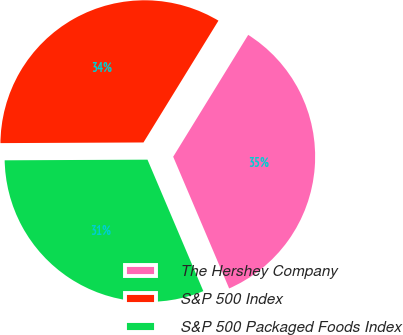Convert chart. <chart><loc_0><loc_0><loc_500><loc_500><pie_chart><fcel>The Hershey Company<fcel>S&P 500 Index<fcel>S&P 500 Packaged Foods Index<nl><fcel>34.82%<fcel>33.85%<fcel>31.32%<nl></chart> 